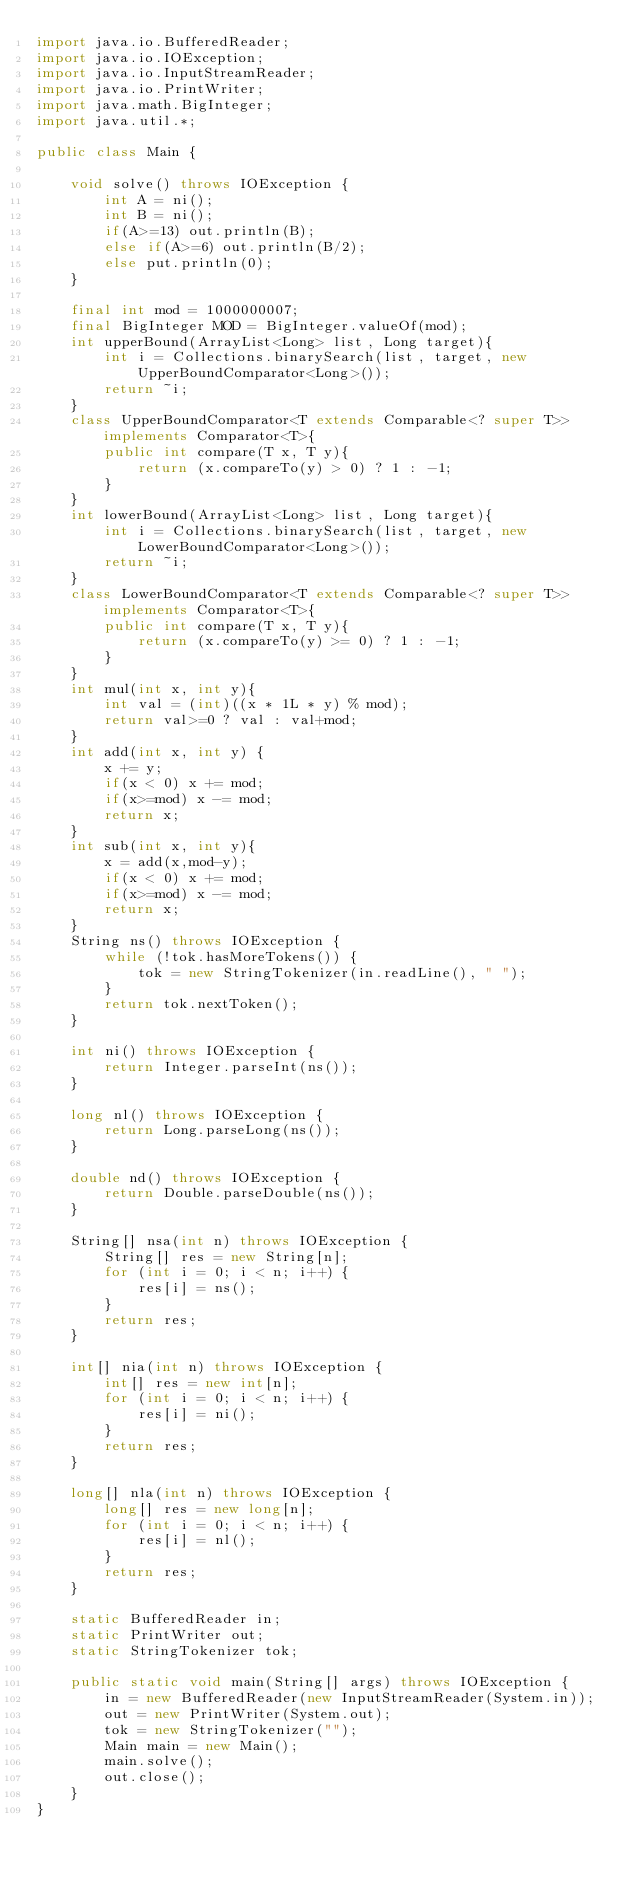Convert code to text. <code><loc_0><loc_0><loc_500><loc_500><_Java_>import java.io.BufferedReader;
import java.io.IOException;
import java.io.InputStreamReader;
import java.io.PrintWriter;
import java.math.BigInteger;
import java.util.*;
 
public class Main {
 
    void solve() throws IOException {
        int A = ni();
        int B = ni();
        if(A>=13) out.println(B);
        else if(A>=6) out.println(B/2);
        else put.println(0);
    }

    final int mod = 1000000007;
    final BigInteger MOD = BigInteger.valueOf(mod);
    int upperBound(ArrayList<Long> list, Long target){
        int i = Collections.binarySearch(list, target, new UpperBoundComparator<Long>());
        return ~i;
    }
    class UpperBoundComparator<T extends Comparable<? super T>> implements Comparator<T>{
        public int compare(T x, T y){
            return (x.compareTo(y) > 0) ? 1 : -1;
        }
    }
    int lowerBound(ArrayList<Long> list, Long target){
        int i = Collections.binarySearch(list, target, new LowerBoundComparator<Long>());
        return ~i;
    }
    class LowerBoundComparator<T extends Comparable<? super T>> implements Comparator<T>{
        public int compare(T x, T y){
            return (x.compareTo(y) >= 0) ? 1 : -1;
        }
    }
    int mul(int x, int y){
        int val = (int)((x * 1L * y) % mod);
        return val>=0 ? val : val+mod;
    }
    int add(int x, int y) {
        x += y;
        if(x < 0) x += mod;
        if(x>=mod) x -= mod;
        return x;
    }
    int sub(int x, int y){
        x = add(x,mod-y);
        if(x < 0) x += mod;
        if(x>=mod) x -= mod;
        return x;
    }
    String ns() throws IOException {
        while (!tok.hasMoreTokens()) {
            tok = new StringTokenizer(in.readLine(), " ");
        }
        return tok.nextToken();
    }
 
    int ni() throws IOException {
        return Integer.parseInt(ns());
    }
 
    long nl() throws IOException {
        return Long.parseLong(ns());
    }
 
    double nd() throws IOException {
        return Double.parseDouble(ns());
    }
 
    String[] nsa(int n) throws IOException {
        String[] res = new String[n];
        for (int i = 0; i < n; i++) {
            res[i] = ns();
        }
        return res;
    }
 
    int[] nia(int n) throws IOException {
        int[] res = new int[n];
        for (int i = 0; i < n; i++) {
            res[i] = ni();
        }
        return res;
    }
 
    long[] nla(int n) throws IOException {
        long[] res = new long[n];
        for (int i = 0; i < n; i++) {
            res[i] = nl();
        }
        return res;
    }
 
    static BufferedReader in;
    static PrintWriter out;
    static StringTokenizer tok;
 
    public static void main(String[] args) throws IOException {
        in = new BufferedReader(new InputStreamReader(System.in));
        out = new PrintWriter(System.out);
        tok = new StringTokenizer("");
        Main main = new Main();
        main.solve();
        out.close();
    }
}</code> 